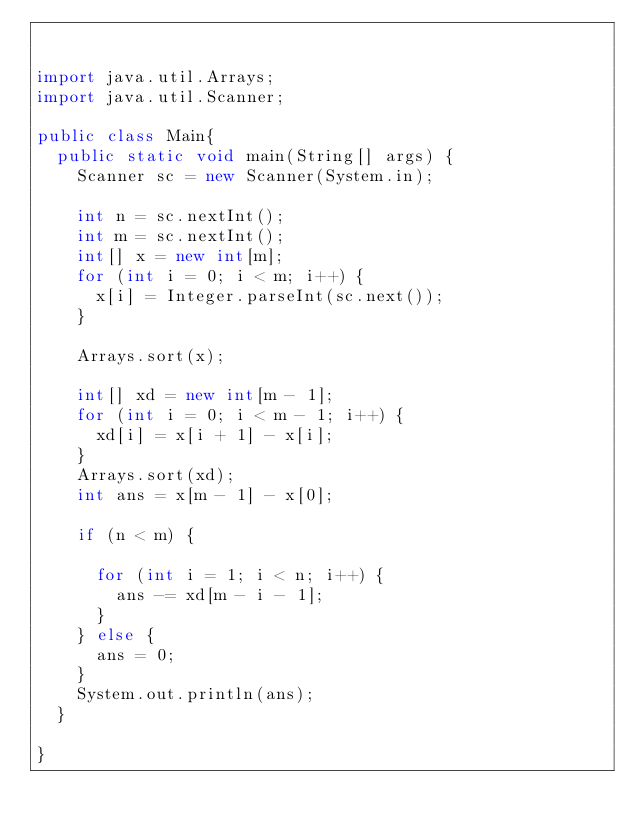<code> <loc_0><loc_0><loc_500><loc_500><_Java_>

import java.util.Arrays;
import java.util.Scanner;

public class Main{
	public static void main(String[] args) {
		Scanner sc = new Scanner(System.in);

		int n = sc.nextInt();
		int m = sc.nextInt();
		int[] x = new int[m];
		for (int i = 0; i < m; i++) {
			x[i] = Integer.parseInt(sc.next());
		}

		Arrays.sort(x);

		int[] xd = new int[m - 1];
		for (int i = 0; i < m - 1; i++) {
			xd[i] = x[i + 1] - x[i];
		}
		Arrays.sort(xd);
		int ans = x[m - 1] - x[0];

		if (n < m) {

			for (int i = 1; i < n; i++) {
				ans -= xd[m - i - 1];
			}
		} else {
			ans = 0;
		}
		System.out.println(ans);
	}

}
</code> 